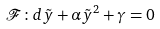Convert formula to latex. <formula><loc_0><loc_0><loc_500><loc_500>\mathcal { F } \colon d \tilde { y } + \alpha \tilde { y } ^ { 2 } + \gamma = 0</formula> 